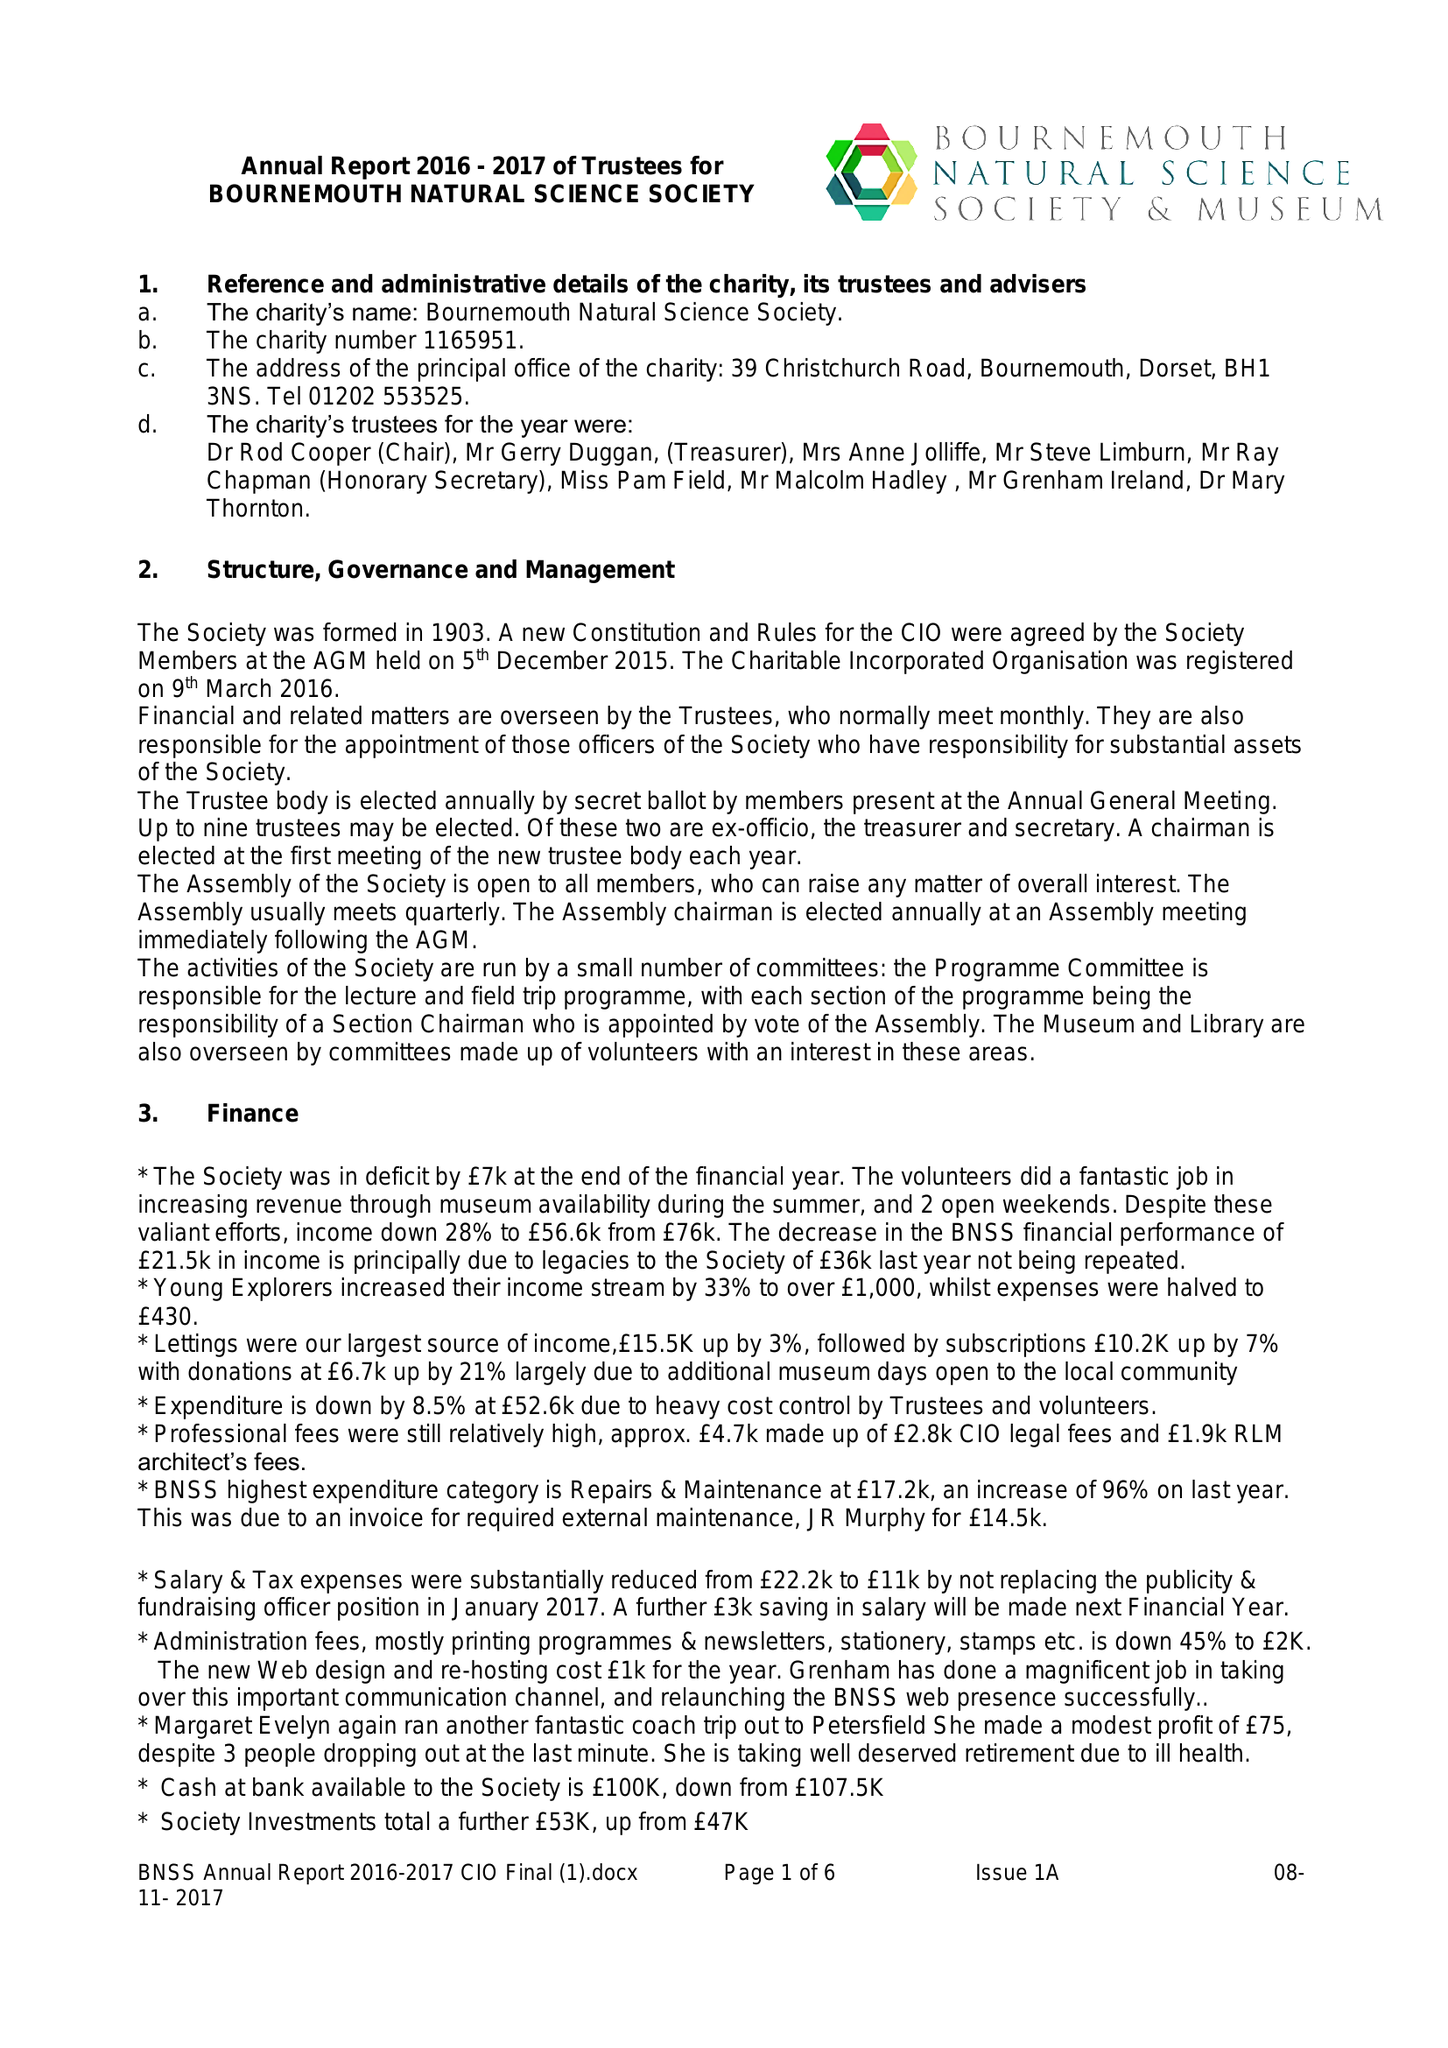What is the value for the report_date?
Answer the question using a single word or phrase. 2017-09-30 